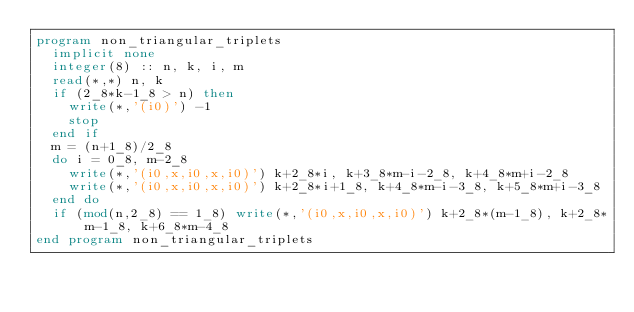Convert code to text. <code><loc_0><loc_0><loc_500><loc_500><_FORTRAN_>program non_triangular_triplets
  implicit none
  integer(8) :: n, k, i, m
  read(*,*) n, k
  if (2_8*k-1_8 > n) then
    write(*,'(i0)') -1
    stop
  end if
  m = (n+1_8)/2_8
  do i = 0_8, m-2_8
    write(*,'(i0,x,i0,x,i0)') k+2_8*i, k+3_8*m-i-2_8, k+4_8*m+i-2_8
    write(*,'(i0,x,i0,x,i0)') k+2_8*i+1_8, k+4_8*m-i-3_8, k+5_8*m+i-3_8
  end do
  if (mod(n,2_8) == 1_8) write(*,'(i0,x,i0,x,i0)') k+2_8*(m-1_8), k+2_8*m-1_8, k+6_8*m-4_8
end program non_triangular_triplets</code> 